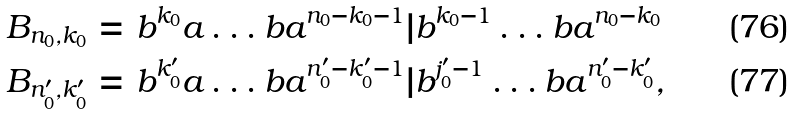<formula> <loc_0><loc_0><loc_500><loc_500>& B _ { n _ { 0 } , k _ { 0 } } = b ^ { k _ { 0 } } a \dots b a ^ { n _ { 0 } - k _ { 0 } - 1 } | b ^ { k _ { 0 } - 1 } \dots b a ^ { n _ { 0 } - k _ { 0 } } \\ & B _ { n _ { 0 } ^ { \prime } , k _ { 0 } ^ { \prime } } = b ^ { k _ { 0 } ^ { \prime } } a \dots b a ^ { n _ { 0 } ^ { \prime } - k _ { 0 } ^ { \prime } - 1 } | b ^ { j _ { 0 } ^ { \prime } - 1 } \dots b a ^ { n _ { 0 } ^ { \prime } - k _ { 0 } ^ { \prime } } ,</formula> 